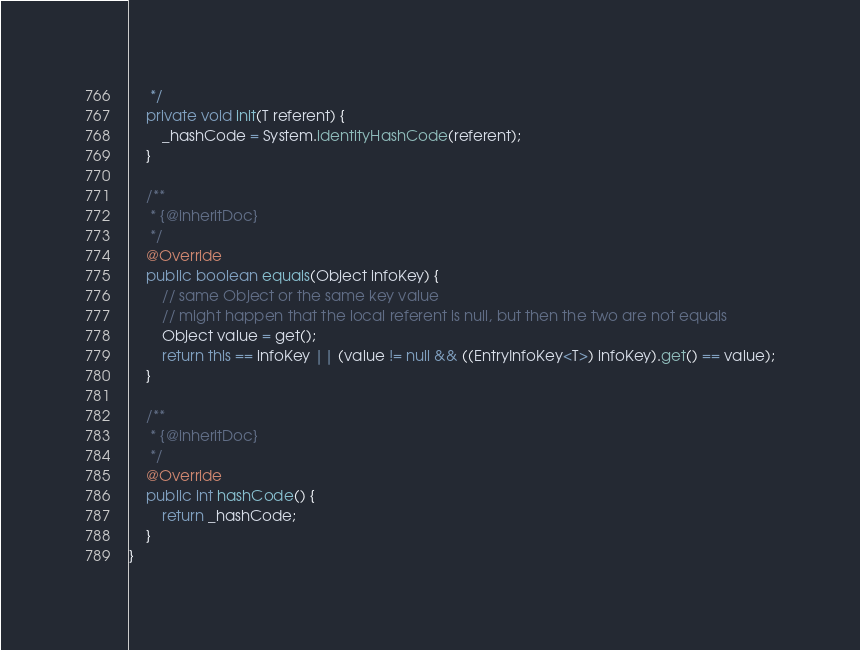<code> <loc_0><loc_0><loc_500><loc_500><_Java_>     */
    private void init(T referent) {
        _hashCode = System.identityHashCode(referent);
    }

    /**
     * {@inheritDoc}
     */
    @Override
    public boolean equals(Object infoKey) {
        // same Object or the same key value
        // might happen that the local referent is null, but then the two are not equals
        Object value = get();
        return this == infoKey || (value != null && ((EntryInfoKey<T>) infoKey).get() == value);
    }

    /**
     * {@inheritDoc}
     */
    @Override
    public int hashCode() {
        return _hashCode;
    }
}</code> 